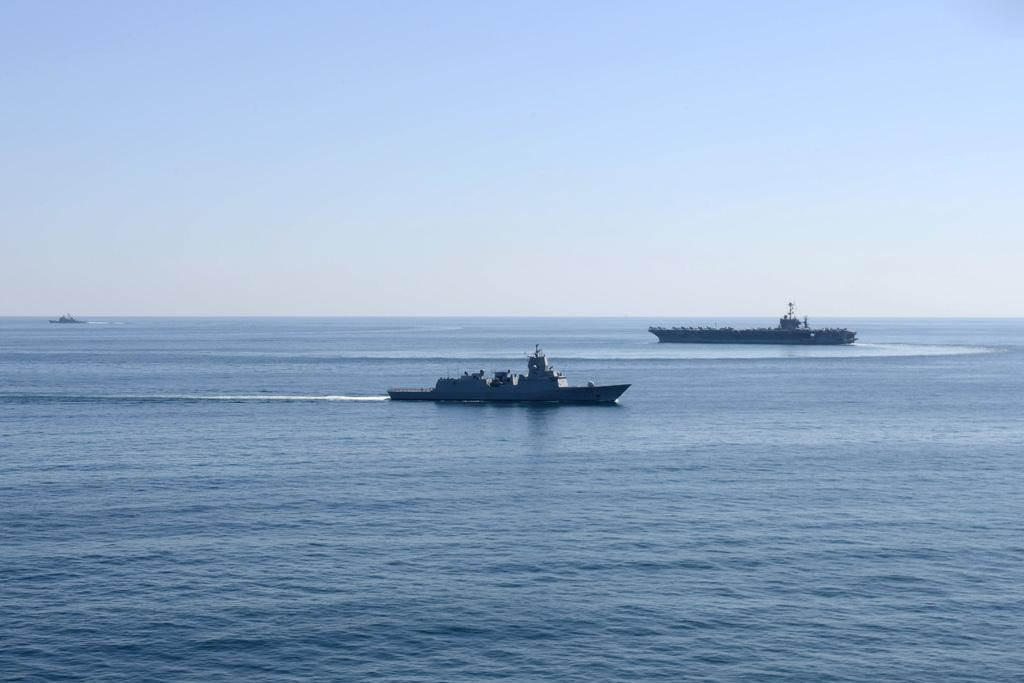How many boats can be seen in the image? There are three boats in the image. Where are the boats located? The boats are in the water. What is visible at the top of the image? The sky is visible at the top of the image. What type of water environment is the image likely taken in? The image is likely taken in the ocean. When was the image likely taken? The image is likely taken during the day. What type of thread is being used for the soda in the image? There is no thread or soda present in the image; it features three boats in the water. What activity is the group of people doing in the image? There are no people visible in the image, so it is not possible to determine what activity they might be doing. 